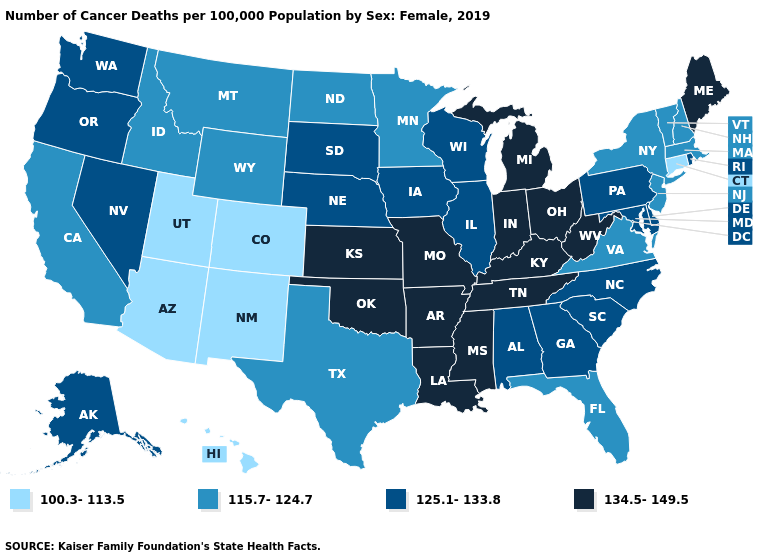Name the states that have a value in the range 125.1-133.8?
Concise answer only. Alabama, Alaska, Delaware, Georgia, Illinois, Iowa, Maryland, Nebraska, Nevada, North Carolina, Oregon, Pennsylvania, Rhode Island, South Carolina, South Dakota, Washington, Wisconsin. Does Tennessee have the lowest value in the USA?
Be succinct. No. Which states hav the highest value in the West?
Give a very brief answer. Alaska, Nevada, Oregon, Washington. Which states have the lowest value in the South?
Concise answer only. Florida, Texas, Virginia. What is the lowest value in the Northeast?
Keep it brief. 100.3-113.5. Among the states that border Utah , which have the highest value?
Answer briefly. Nevada. What is the value of North Dakota?
Concise answer only. 115.7-124.7. Name the states that have a value in the range 100.3-113.5?
Concise answer only. Arizona, Colorado, Connecticut, Hawaii, New Mexico, Utah. What is the value of Arizona?
Be succinct. 100.3-113.5. Among the states that border Wyoming , does Utah have the lowest value?
Quick response, please. Yes. Which states have the lowest value in the West?
Short answer required. Arizona, Colorado, Hawaii, New Mexico, Utah. Which states have the lowest value in the MidWest?
Concise answer only. Minnesota, North Dakota. Name the states that have a value in the range 125.1-133.8?
Answer briefly. Alabama, Alaska, Delaware, Georgia, Illinois, Iowa, Maryland, Nebraska, Nevada, North Carolina, Oregon, Pennsylvania, Rhode Island, South Carolina, South Dakota, Washington, Wisconsin. What is the highest value in states that border South Dakota?
Be succinct. 125.1-133.8. Which states have the highest value in the USA?
Quick response, please. Arkansas, Indiana, Kansas, Kentucky, Louisiana, Maine, Michigan, Mississippi, Missouri, Ohio, Oklahoma, Tennessee, West Virginia. 